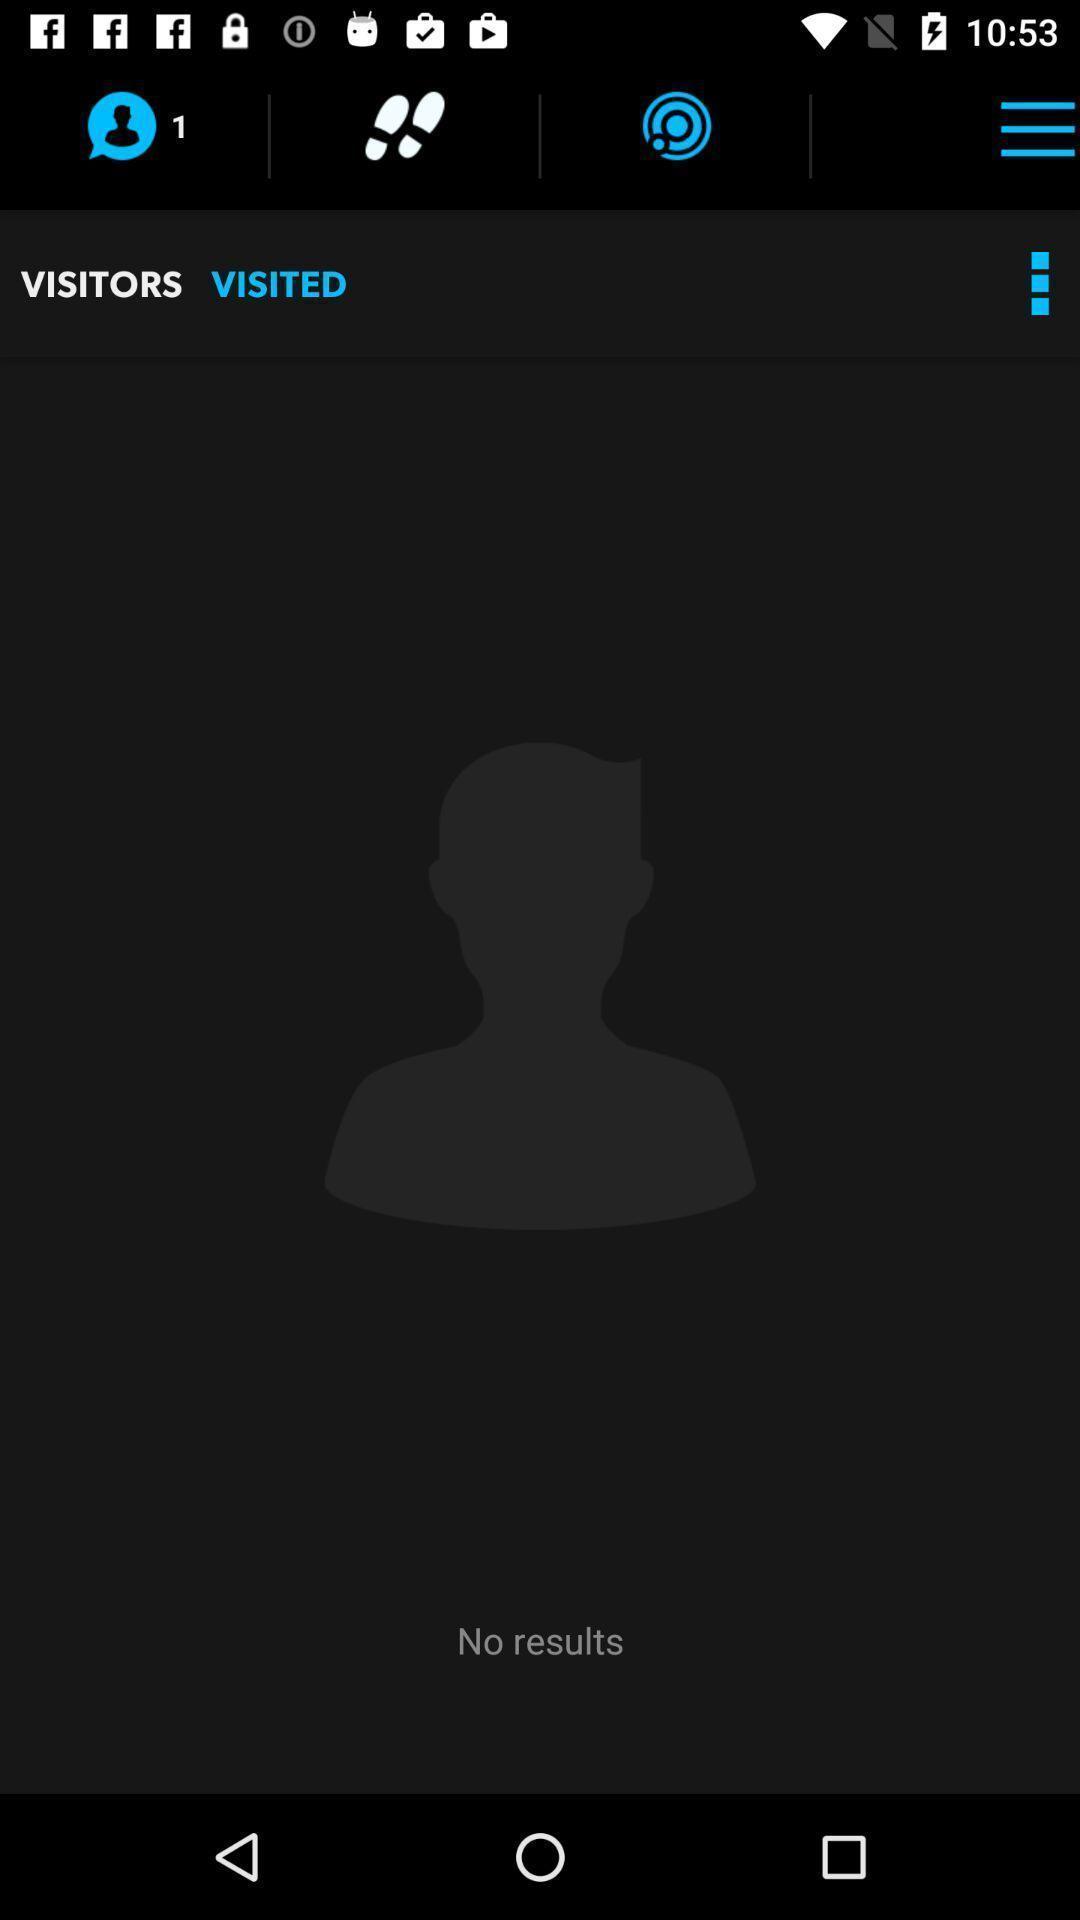Provide a textual representation of this image. Screen page displaying the status of results and other options. 